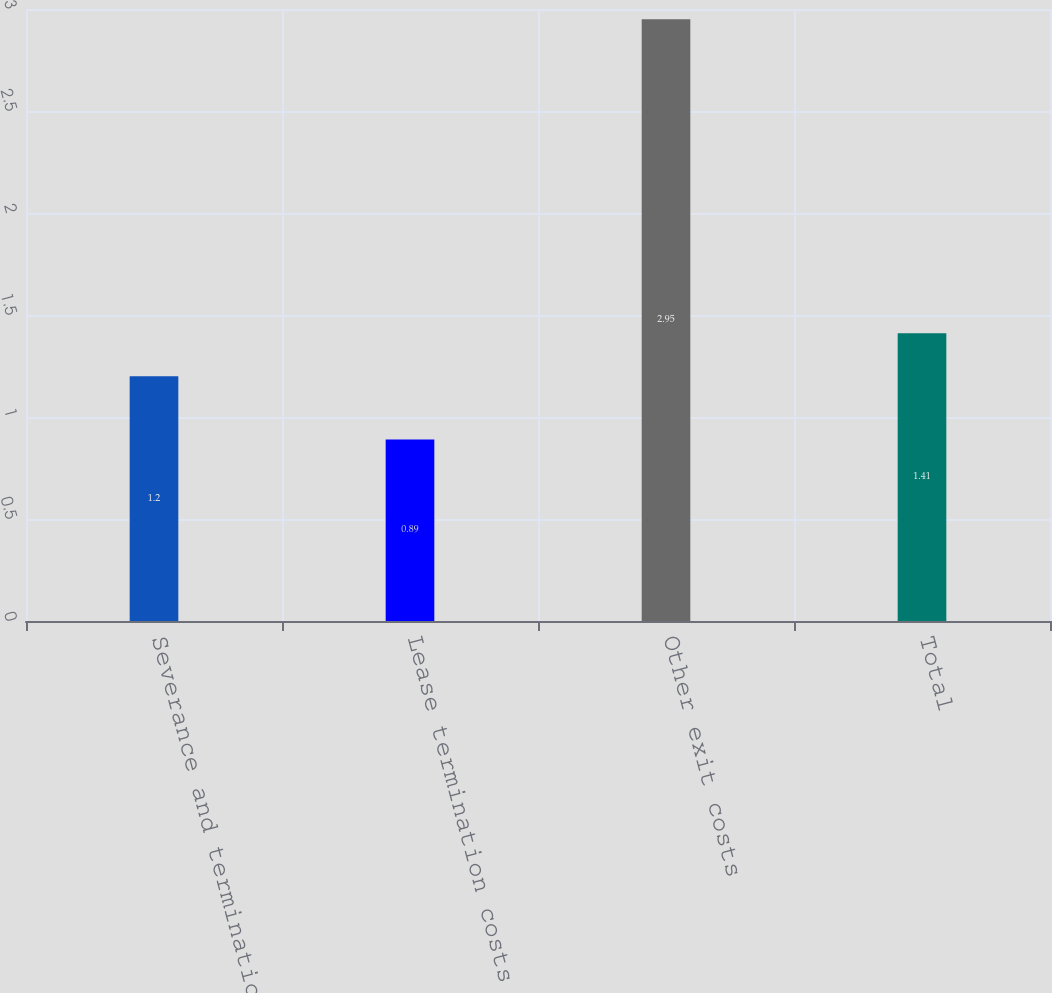<chart> <loc_0><loc_0><loc_500><loc_500><bar_chart><fcel>Severance and termination<fcel>Lease termination costs<fcel>Other exit costs<fcel>Total<nl><fcel>1.2<fcel>0.89<fcel>2.95<fcel>1.41<nl></chart> 